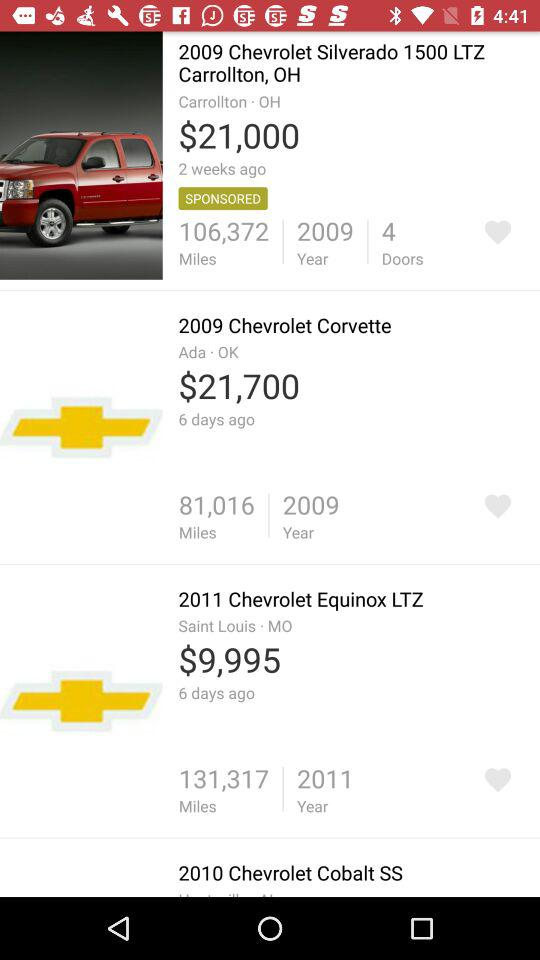Which car has driven 1301370 kilometers?
When the provided information is insufficient, respond with <no answer>. <no answer> 